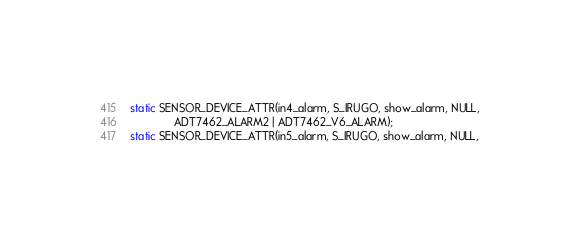<code> <loc_0><loc_0><loc_500><loc_500><_C_>static SENSOR_DEVICE_ATTR(in4_alarm, S_IRUGO, show_alarm, NULL,
			  ADT7462_ALARM2 | ADT7462_V6_ALARM);
static SENSOR_DEVICE_ATTR(in5_alarm, S_IRUGO, show_alarm, NULL,</code> 